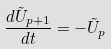Convert formula to latex. <formula><loc_0><loc_0><loc_500><loc_500>\frac { d \tilde { U } _ { p + 1 } } { d t } = - \tilde { U } _ { p }</formula> 